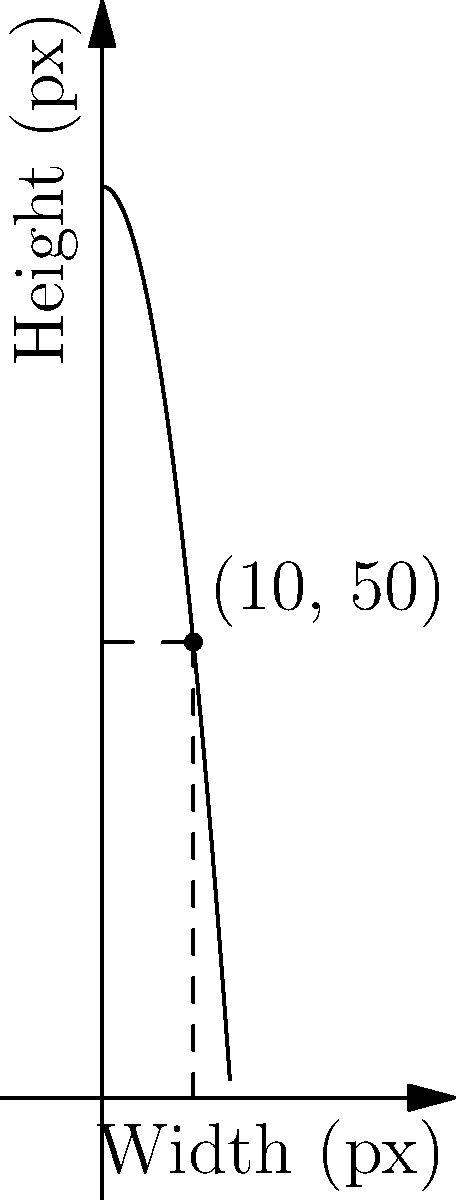In an open-source responsive web layout project, you're designing a component that adjusts its height based on its width. The relationship between width ($w$) and height ($h$) is given by the function $h = 100 - 0.5w^2$, where both dimensions are in pixels. If the width is set to 10 pixels, what height should be used to maintain the optimal aspect ratio? To solve this problem, we need to follow these steps:

1. Identify the given function: $h = 100 - 0.5w^2$
2. We know that the width ($w$) is 10 pixels
3. Substitute $w = 10$ into the function:
   $h = 100 - 0.5(10)^2$
4. Calculate:
   $h = 100 - 0.5(100)$
   $h = 100 - 50$
   $h = 50$

Therefore, when the width is 10 pixels, the optimal height to maintain the aspect ratio is 50 pixels.

This result can be visualized on the graph, where the point (10, 50) lies on the curve representing the function.
Answer: 50 pixels 